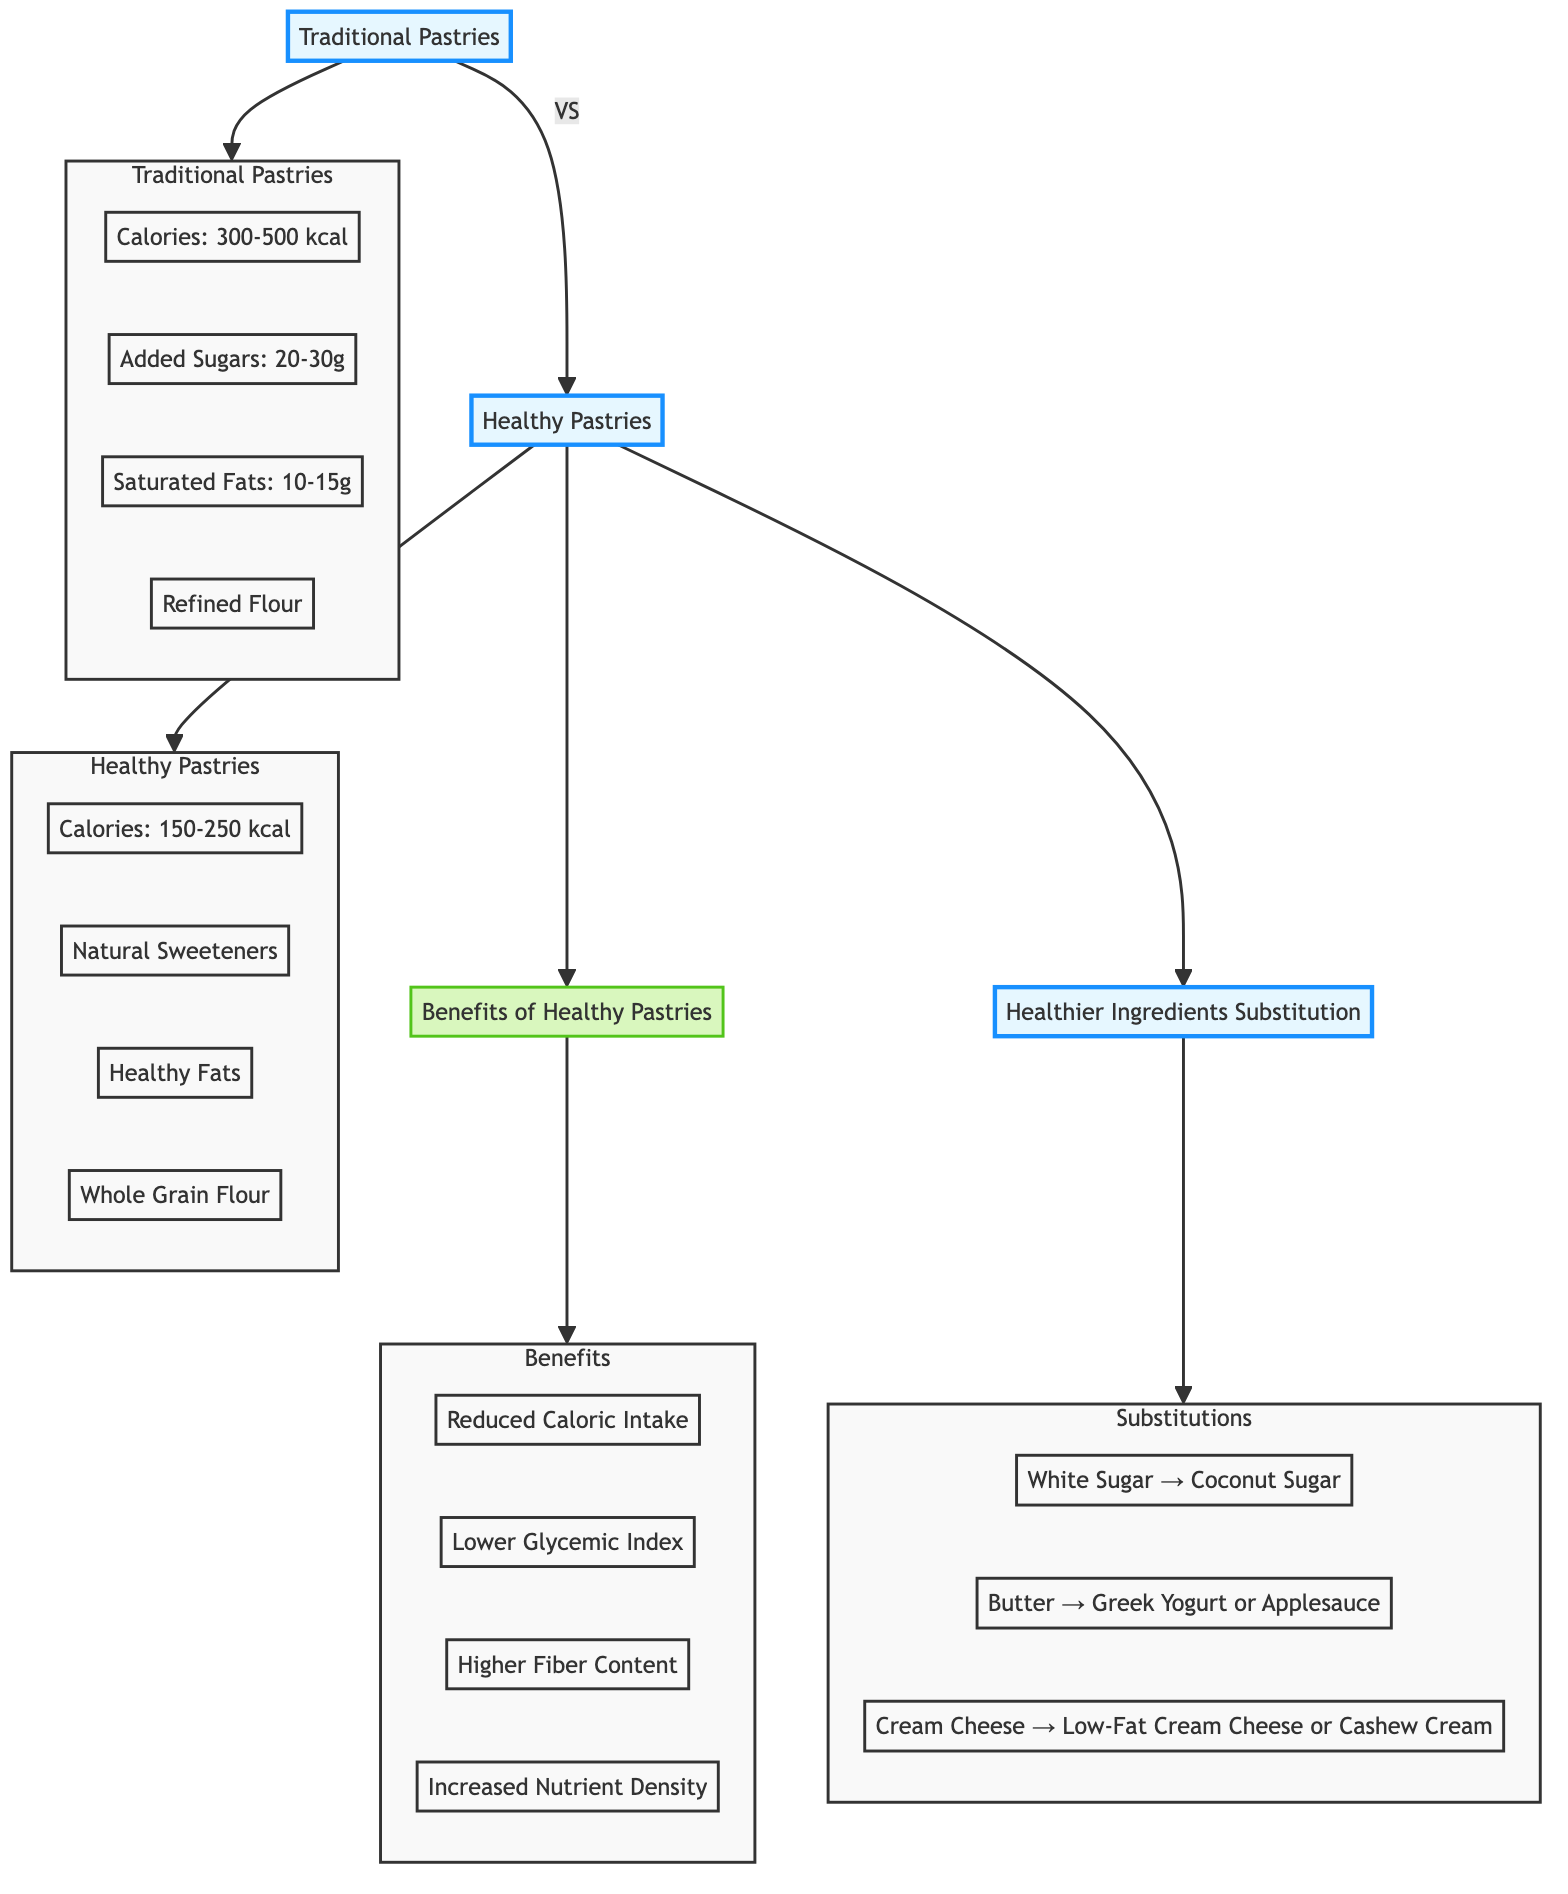What is the calorie range for traditional pastries? The diagram specifies that traditional pastries have a calorie range of 300-500 kcal per serving. This information is directly presented in the attributes of the "Traditional Pastries" node.
Answer: 300-500 kcal What type of flour is commonly used in traditional pastries? According to the attributes of the "Traditional Pastries" node in the diagram, refined flour is commonly used.
Answer: Refined Flour What is the sugar content of healthy pastries? The attributes of the "Healthy Pastries" node indicate that healthy pastries use natural sweeteners, which do not quantify sugar content like traditional pastries. The presence of "Natural Sweeteners" suggests alternatives to traditional sugars.
Answer: Natural Sweeteners Which health benefit has the highest impact according to the diagram? The benefits of healthy pastries include reduced caloric intake, lower glycemic index, higher fiber content, and increased nutrient density. They are listed under "Benefits of Healthy Pastries," but there’s no quantitative measure to determine which is "highest," leading to a subjective interpretation. However, based on common understanding, "Reduced Caloric Intake" might be considered impactful.
Answer: Reduced Caloric Intake What ingredient substitutes healthy fat for butter? The "Healthier Ingredients Substitution" section in the diagram specifies that butter can be substituted with Greek yogurt or applesauce, indicating healthier alternatives for fat content.
Answer: Greek Yogurt or Applesauce How many health benefits are there listed in the diagram? The "Benefits of Healthy Pastries" node indicates that there are four distinct benefits listed in the diagram: reduced caloric intake, lower glycemic index, higher fiber content, and increased nutrient density. Thus, the total count can be established directly by counting these listed benefits.
Answer: 4 Which category follows healthy pastries in the diagram? The flow chart shows that the "Benefits of Healthy Pastries" follows after "Healthy Pastries," establishing a direct connection between the two nodes in the flow.
Answer: Benefits of Healthy Pastries What is the relationship between traditional pastries and healthy pastries? The diagram shows a direct linkage labeled "VS," representing a comparison between traditional pastries and healthy pastries, highlighting the distinct differences between the two categories visually.
Answer: VS Which sweetener is a healthy substitute for white sugar? The "Healthier Ingredients Substitution" section indicates that coconut sugar is a healthy substitute for white sugar, demonstrating an example of healthier ingredient swaps.
Answer: Coconut Sugar 